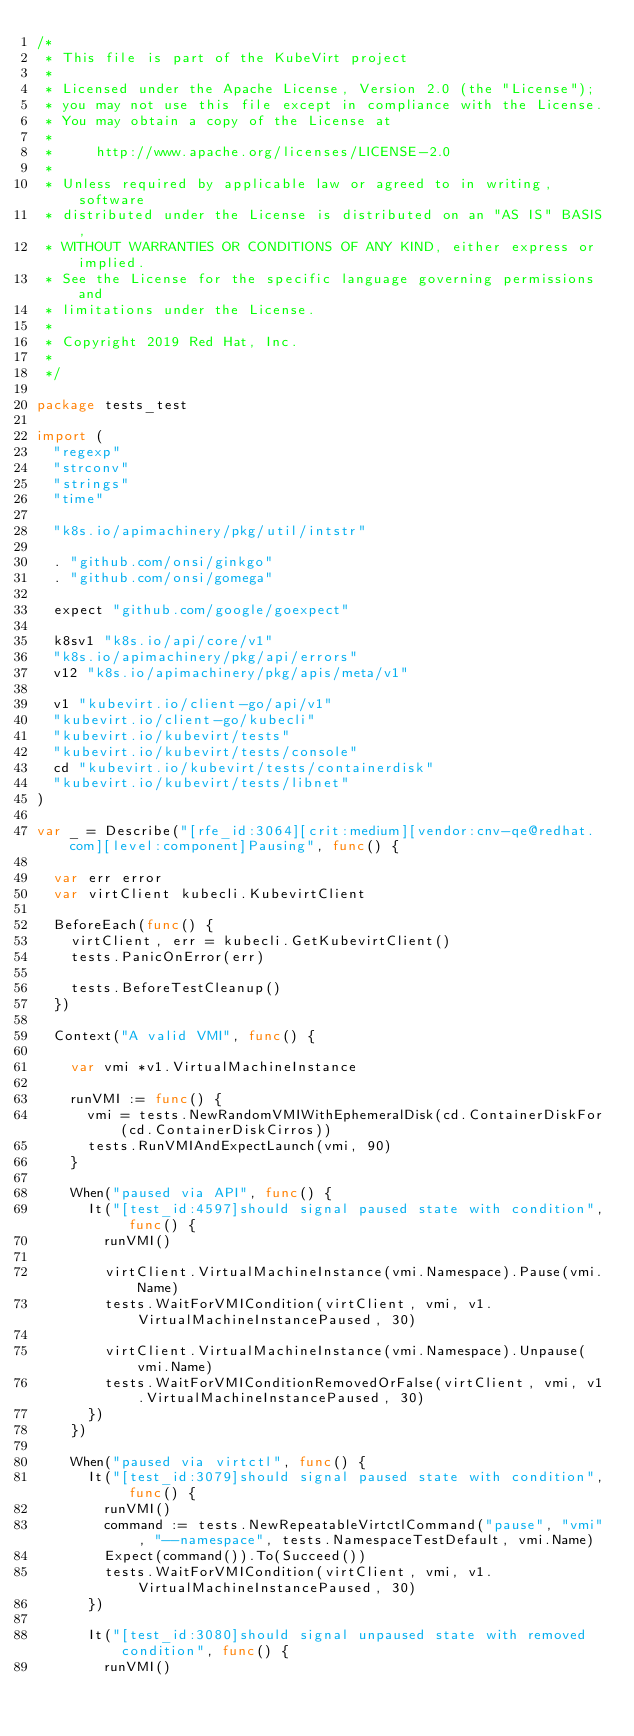<code> <loc_0><loc_0><loc_500><loc_500><_Go_>/*
 * This file is part of the KubeVirt project
 *
 * Licensed under the Apache License, Version 2.0 (the "License");
 * you may not use this file except in compliance with the License.
 * You may obtain a copy of the License at
 *
 *     http://www.apache.org/licenses/LICENSE-2.0
 *
 * Unless required by applicable law or agreed to in writing, software
 * distributed under the License is distributed on an "AS IS" BASIS,
 * WITHOUT WARRANTIES OR CONDITIONS OF ANY KIND, either express or implied.
 * See the License for the specific language governing permissions and
 * limitations under the License.
 *
 * Copyright 2019 Red Hat, Inc.
 *
 */

package tests_test

import (
	"regexp"
	"strconv"
	"strings"
	"time"

	"k8s.io/apimachinery/pkg/util/intstr"

	. "github.com/onsi/ginkgo"
	. "github.com/onsi/gomega"

	expect "github.com/google/goexpect"

	k8sv1 "k8s.io/api/core/v1"
	"k8s.io/apimachinery/pkg/api/errors"
	v12 "k8s.io/apimachinery/pkg/apis/meta/v1"

	v1 "kubevirt.io/client-go/api/v1"
	"kubevirt.io/client-go/kubecli"
	"kubevirt.io/kubevirt/tests"
	"kubevirt.io/kubevirt/tests/console"
	cd "kubevirt.io/kubevirt/tests/containerdisk"
	"kubevirt.io/kubevirt/tests/libnet"
)

var _ = Describe("[rfe_id:3064][crit:medium][vendor:cnv-qe@redhat.com][level:component]Pausing", func() {

	var err error
	var virtClient kubecli.KubevirtClient

	BeforeEach(func() {
		virtClient, err = kubecli.GetKubevirtClient()
		tests.PanicOnError(err)

		tests.BeforeTestCleanup()
	})

	Context("A valid VMI", func() {

		var vmi *v1.VirtualMachineInstance

		runVMI := func() {
			vmi = tests.NewRandomVMIWithEphemeralDisk(cd.ContainerDiskFor(cd.ContainerDiskCirros))
			tests.RunVMIAndExpectLaunch(vmi, 90)
		}

		When("paused via API", func() {
			It("[test_id:4597]should signal paused state with condition", func() {
				runVMI()

				virtClient.VirtualMachineInstance(vmi.Namespace).Pause(vmi.Name)
				tests.WaitForVMICondition(virtClient, vmi, v1.VirtualMachineInstancePaused, 30)

				virtClient.VirtualMachineInstance(vmi.Namespace).Unpause(vmi.Name)
				tests.WaitForVMIConditionRemovedOrFalse(virtClient, vmi, v1.VirtualMachineInstancePaused, 30)
			})
		})

		When("paused via virtctl", func() {
			It("[test_id:3079]should signal paused state with condition", func() {
				runVMI()
				command := tests.NewRepeatableVirtctlCommand("pause", "vmi", "--namespace", tests.NamespaceTestDefault, vmi.Name)
				Expect(command()).To(Succeed())
				tests.WaitForVMICondition(virtClient, vmi, v1.VirtualMachineInstancePaused, 30)
			})

			It("[test_id:3080]should signal unpaused state with removed condition", func() {
				runVMI()</code> 